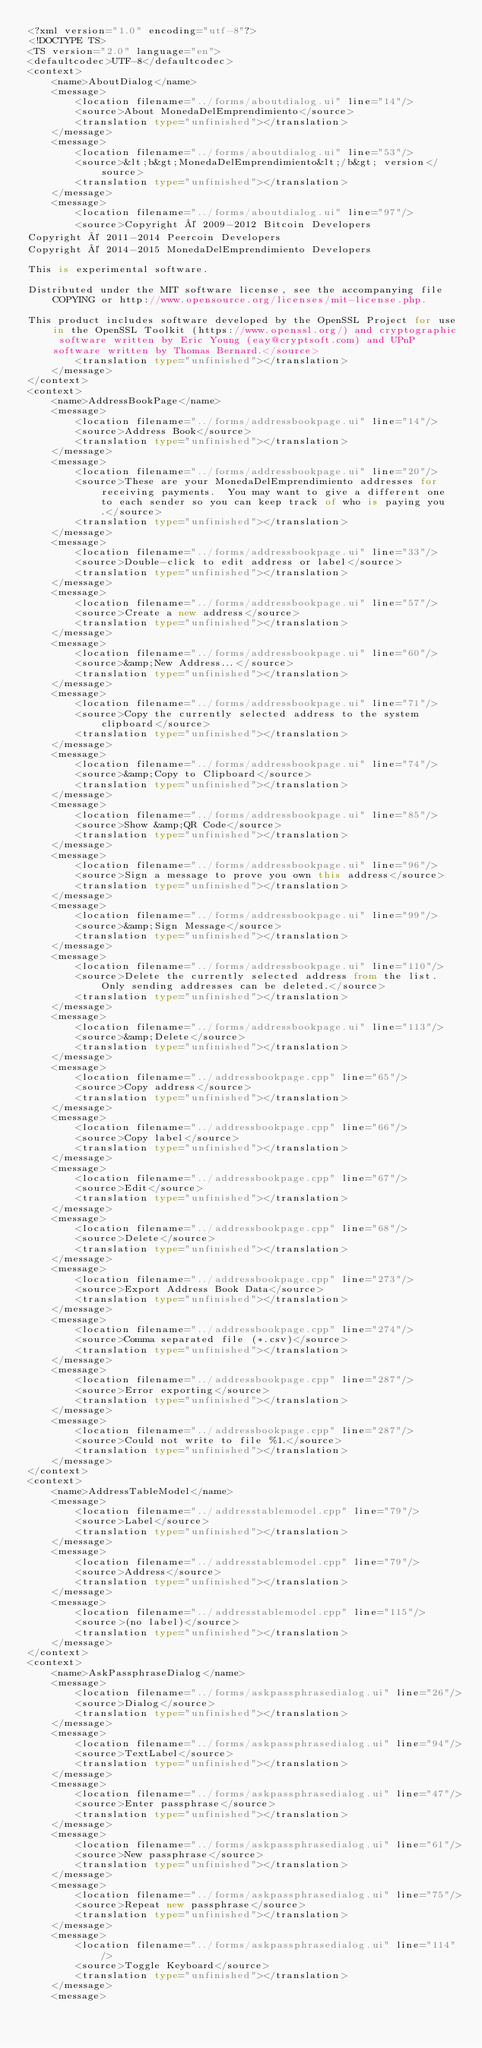<code> <loc_0><loc_0><loc_500><loc_500><_TypeScript_><?xml version="1.0" encoding="utf-8"?>
<!DOCTYPE TS>
<TS version="2.0" language="en">
<defaultcodec>UTF-8</defaultcodec>
<context>
    <name>AboutDialog</name>
    <message>
        <location filename="../forms/aboutdialog.ui" line="14"/>
        <source>About MonedaDelEmprendimiento</source>
        <translation type="unfinished"></translation>
    </message>
    <message>
        <location filename="../forms/aboutdialog.ui" line="53"/>
        <source>&lt;b&gt;MonedaDelEmprendimiento&lt;/b&gt; version</source>
        <translation type="unfinished"></translation>
    </message>
    <message>
        <location filename="../forms/aboutdialog.ui" line="97"/>
        <source>Copyright © 2009-2012 Bitcoin Developers
Copyright © 2011-2014 Peercoin Developers
Copyright © 2014-2015 MonedaDelEmprendimiento Developers

This is experimental software.

Distributed under the MIT software license, see the accompanying file COPYING or http://www.opensource.org/licenses/mit-license.php.

This product includes software developed by the OpenSSL Project for use in the OpenSSL Toolkit (https://www.openssl.org/) and cryptographic software written by Eric Young (eay@cryptsoft.com) and UPnP software written by Thomas Bernard.</source>
        <translation type="unfinished"></translation>
    </message>
</context>
<context>
    <name>AddressBookPage</name>
    <message>
        <location filename="../forms/addressbookpage.ui" line="14"/>
        <source>Address Book</source>
        <translation type="unfinished"></translation>
    </message>
    <message>
        <location filename="../forms/addressbookpage.ui" line="20"/>
        <source>These are your MonedaDelEmprendimiento addresses for receiving payments.  You may want to give a different one to each sender so you can keep track of who is paying you.</source>
        <translation type="unfinished"></translation>
    </message>
    <message>
        <location filename="../forms/addressbookpage.ui" line="33"/>
        <source>Double-click to edit address or label</source>
        <translation type="unfinished"></translation>
    </message>
    <message>
        <location filename="../forms/addressbookpage.ui" line="57"/>
        <source>Create a new address</source>
        <translation type="unfinished"></translation>
    </message>
    <message>
        <location filename="../forms/addressbookpage.ui" line="60"/>
        <source>&amp;New Address...</source>
        <translation type="unfinished"></translation>
    </message>
    <message>
        <location filename="../forms/addressbookpage.ui" line="71"/>
        <source>Copy the currently selected address to the system clipboard</source>
        <translation type="unfinished"></translation>
    </message>
    <message>
        <location filename="../forms/addressbookpage.ui" line="74"/>
        <source>&amp;Copy to Clipboard</source>
        <translation type="unfinished"></translation>
    </message>
    <message>
        <location filename="../forms/addressbookpage.ui" line="85"/>
        <source>Show &amp;QR Code</source>
        <translation type="unfinished"></translation>
    </message>
    <message>
        <location filename="../forms/addressbookpage.ui" line="96"/>
        <source>Sign a message to prove you own this address</source>
        <translation type="unfinished"></translation>
    </message>
    <message>
        <location filename="../forms/addressbookpage.ui" line="99"/>
        <source>&amp;Sign Message</source>
        <translation type="unfinished"></translation>
    </message>
    <message>
        <location filename="../forms/addressbookpage.ui" line="110"/>
        <source>Delete the currently selected address from the list. Only sending addresses can be deleted.</source>
        <translation type="unfinished"></translation>
    </message>
    <message>
        <location filename="../forms/addressbookpage.ui" line="113"/>
        <source>&amp;Delete</source>
        <translation type="unfinished"></translation>
    </message>
    <message>
        <location filename="../addressbookpage.cpp" line="65"/>
        <source>Copy address</source>
        <translation type="unfinished"></translation>
    </message>
    <message>
        <location filename="../addressbookpage.cpp" line="66"/>
        <source>Copy label</source>
        <translation type="unfinished"></translation>
    </message>
    <message>
        <location filename="../addressbookpage.cpp" line="67"/>
        <source>Edit</source>
        <translation type="unfinished"></translation>
    </message>
    <message>
        <location filename="../addressbookpage.cpp" line="68"/>
        <source>Delete</source>
        <translation type="unfinished"></translation>
    </message>
    <message>
        <location filename="../addressbookpage.cpp" line="273"/>
        <source>Export Address Book Data</source>
        <translation type="unfinished"></translation>
    </message>
    <message>
        <location filename="../addressbookpage.cpp" line="274"/>
        <source>Comma separated file (*.csv)</source>
        <translation type="unfinished"></translation>
    </message>
    <message>
        <location filename="../addressbookpage.cpp" line="287"/>
        <source>Error exporting</source>
        <translation type="unfinished"></translation>
    </message>
    <message>
        <location filename="../addressbookpage.cpp" line="287"/>
        <source>Could not write to file %1.</source>
        <translation type="unfinished"></translation>
    </message>
</context>
<context>
    <name>AddressTableModel</name>
    <message>
        <location filename="../addresstablemodel.cpp" line="79"/>
        <source>Label</source>
        <translation type="unfinished"></translation>
    </message>
    <message>
        <location filename="../addresstablemodel.cpp" line="79"/>
        <source>Address</source>
        <translation type="unfinished"></translation>
    </message>
    <message>
        <location filename="../addresstablemodel.cpp" line="115"/>
        <source>(no label)</source>
        <translation type="unfinished"></translation>
    </message>
</context>
<context>
    <name>AskPassphraseDialog</name>
    <message>
        <location filename="../forms/askpassphrasedialog.ui" line="26"/>
        <source>Dialog</source>
        <translation type="unfinished"></translation>
    </message>
    <message>
        <location filename="../forms/askpassphrasedialog.ui" line="94"/>
        <source>TextLabel</source>
        <translation type="unfinished"></translation>
    </message>
    <message>
        <location filename="../forms/askpassphrasedialog.ui" line="47"/>
        <source>Enter passphrase</source>
        <translation type="unfinished"></translation>
    </message>
    <message>
        <location filename="../forms/askpassphrasedialog.ui" line="61"/>
        <source>New passphrase</source>
        <translation type="unfinished"></translation>
    </message>
    <message>
        <location filename="../forms/askpassphrasedialog.ui" line="75"/>
        <source>Repeat new passphrase</source>
        <translation type="unfinished"></translation>
    </message>
    <message>
        <location filename="../forms/askpassphrasedialog.ui" line="114"/>
        <source>Toggle Keyboard</source>
        <translation type="unfinished"></translation>
    </message>
    <message></code> 